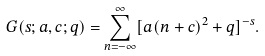Convert formula to latex. <formula><loc_0><loc_0><loc_500><loc_500>G ( s ; a , c ; q ) = \sum _ { n = - \infty } ^ { \infty } [ a ( n + c ) ^ { 2 } + q ] ^ { - s } .</formula> 